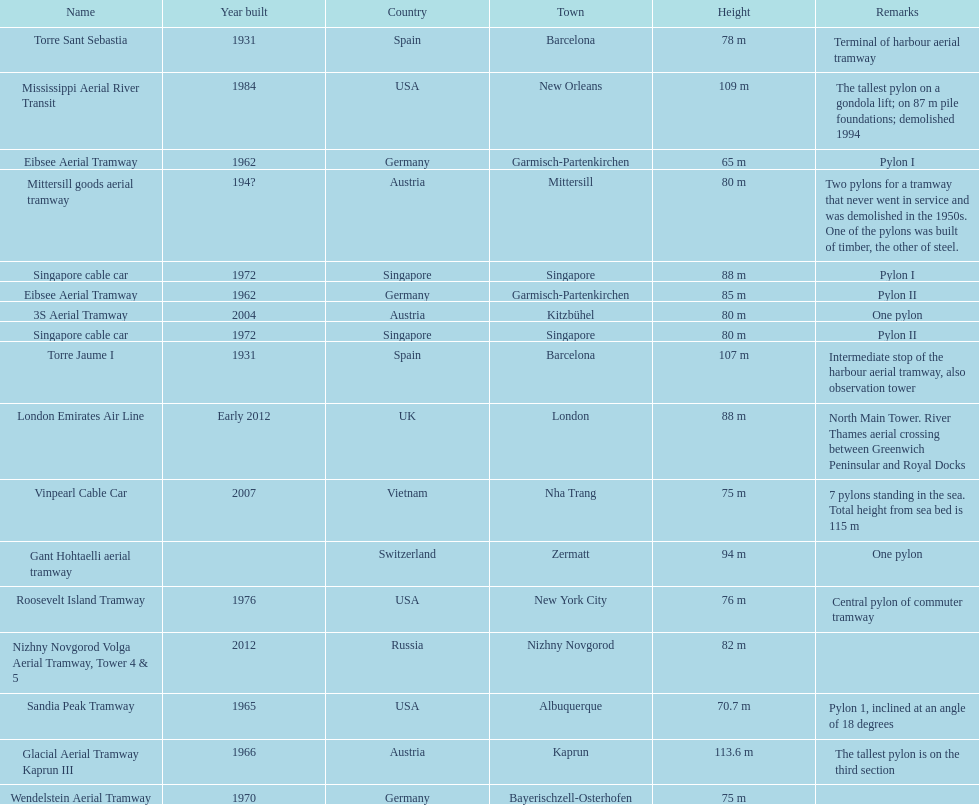Can you give me this table as a dict? {'header': ['Name', 'Year built', 'Country', 'Town', 'Height', 'Remarks'], 'rows': [['Torre Sant Sebastia', '1931', 'Spain', 'Barcelona', '78 m', 'Terminal of harbour aerial tramway'], ['Mississippi Aerial River Transit', '1984', 'USA', 'New Orleans', '109 m', 'The tallest pylon on a gondola lift; on 87 m pile foundations; demolished 1994'], ['Eibsee Aerial Tramway', '1962', 'Germany', 'Garmisch-Partenkirchen', '65 m', 'Pylon I'], ['Mittersill goods aerial tramway', '194?', 'Austria', 'Mittersill', '80 m', 'Two pylons for a tramway that never went in service and was demolished in the 1950s. One of the pylons was built of timber, the other of steel.'], ['Singapore cable car', '1972', 'Singapore', 'Singapore', '88 m', 'Pylon I'], ['Eibsee Aerial Tramway', '1962', 'Germany', 'Garmisch-Partenkirchen', '85 m', 'Pylon II'], ['3S Aerial Tramway', '2004', 'Austria', 'Kitzbühel', '80 m', 'One pylon'], ['Singapore cable car', '1972', 'Singapore', 'Singapore', '80 m', 'Pylon II'], ['Torre Jaume I', '1931', 'Spain', 'Barcelona', '107 m', 'Intermediate stop of the harbour aerial tramway, also observation tower'], ['London Emirates Air Line', 'Early 2012', 'UK', 'London', '88 m', 'North Main Tower. River Thames aerial crossing between Greenwich Peninsular and Royal Docks'], ['Vinpearl Cable Car', '2007', 'Vietnam', 'Nha Trang', '75 m', '7 pylons standing in the sea. Total height from sea bed is 115 m'], ['Gant Hohtaelli aerial tramway', '', 'Switzerland', 'Zermatt', '94 m', 'One pylon'], ['Roosevelt Island Tramway', '1976', 'USA', 'New York City', '76 m', 'Central pylon of commuter tramway'], ['Nizhny Novgorod Volga Aerial Tramway, Tower 4 & 5', '2012', 'Russia', 'Nizhny Novgorod', '82 m', ''], ['Sandia Peak Tramway', '1965', 'USA', 'Albuquerque', '70.7 m', 'Pylon 1, inclined at an angle of 18 degrees'], ['Glacial Aerial Tramway Kaprun III', '1966', 'Austria', 'Kaprun', '113.6 m', 'The tallest pylon is on the third section'], ['Wendelstein Aerial Tramway', '1970', 'Germany', 'Bayerischzell-Osterhofen', '75 m', '']]} How many pylons are at least 80 meters tall? 11. 